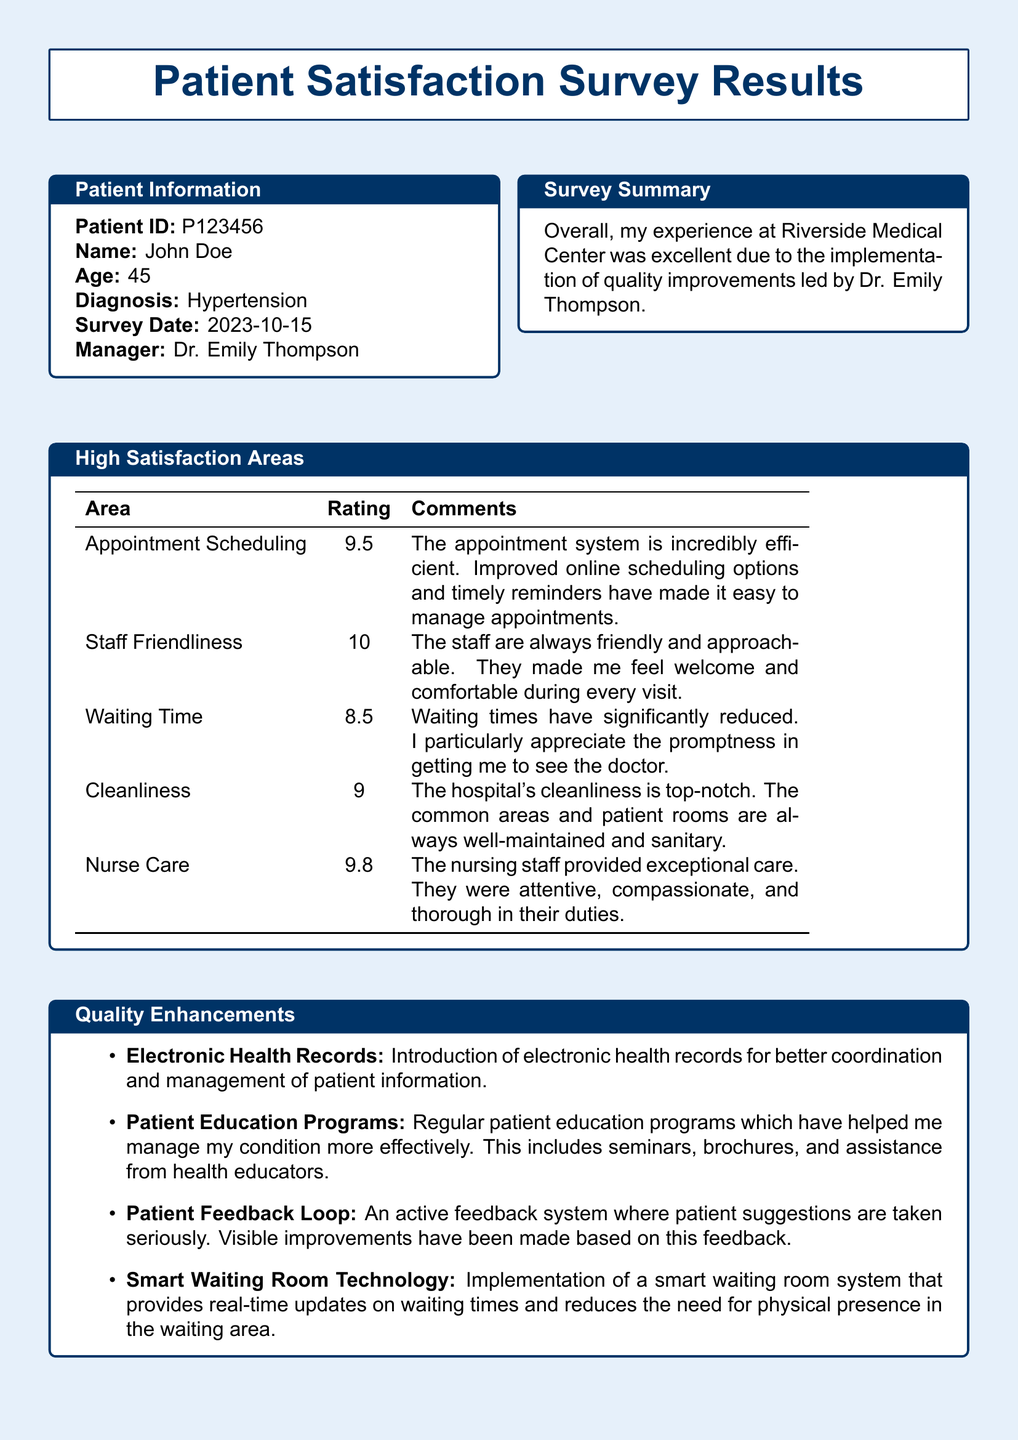What is the patient ID? The patient ID is listed in the patient information section of the document.
Answer: P123456 Who is the manager mentioned in the document? The manager is mentioned in the context of quality improvement efforts.
Answer: Dr. Emily Thompson What was the satisfaction rating for Staff Friendliness? The satisfaction rating for Staff Friendliness is found in the High Satisfaction Areas table.
Answer: 10 What type of technology was implemented in the waiting room? The document describes a specific improvement in the waiting room technology.
Answer: Smart Waiting Room Technology How many areas of high satisfaction are reported in the document? The number of areas is indicated in the corresponding section of the document.
Answer: 5 What date was the survey completed? The date of the survey is stated in the patient information section.
Answer: 2023-10-15 Which area received the lowest satisfaction rating? The area with the lowest rating can be determined from the High Satisfaction Areas table.
Answer: Waiting Time What is one method mentioned for patient education? The document lists specific enhancements related to patient education and their types in a bullet point.
Answer: Seminars 